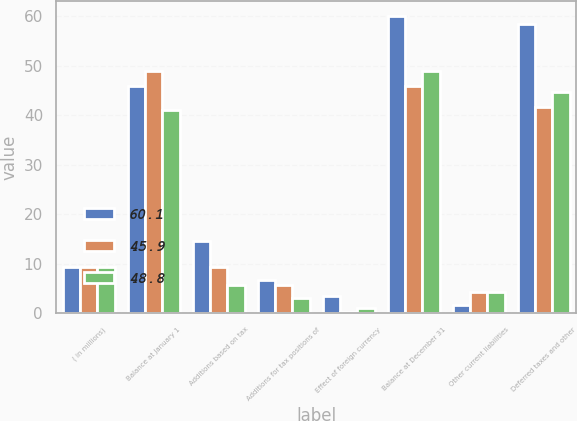<chart> <loc_0><loc_0><loc_500><loc_500><stacked_bar_chart><ecel><fcel>( in millions)<fcel>Balance at January 1<fcel>Additions based on tax<fcel>Additions for tax positions of<fcel>Effect of foreign currency<fcel>Balance at December 31<fcel>Other current liabilities<fcel>Deferred taxes and other<nl><fcel>60.1<fcel>9.4<fcel>45.9<fcel>14.5<fcel>6.7<fcel>3.5<fcel>60.1<fcel>1.7<fcel>58.4<nl><fcel>45.9<fcel>9.4<fcel>48.8<fcel>9.4<fcel>5.6<fcel>0.3<fcel>45.9<fcel>4.2<fcel>41.7<nl><fcel>48.8<fcel>9.4<fcel>41.1<fcel>5.6<fcel>3.1<fcel>1<fcel>48.8<fcel>4.2<fcel>44.6<nl></chart> 